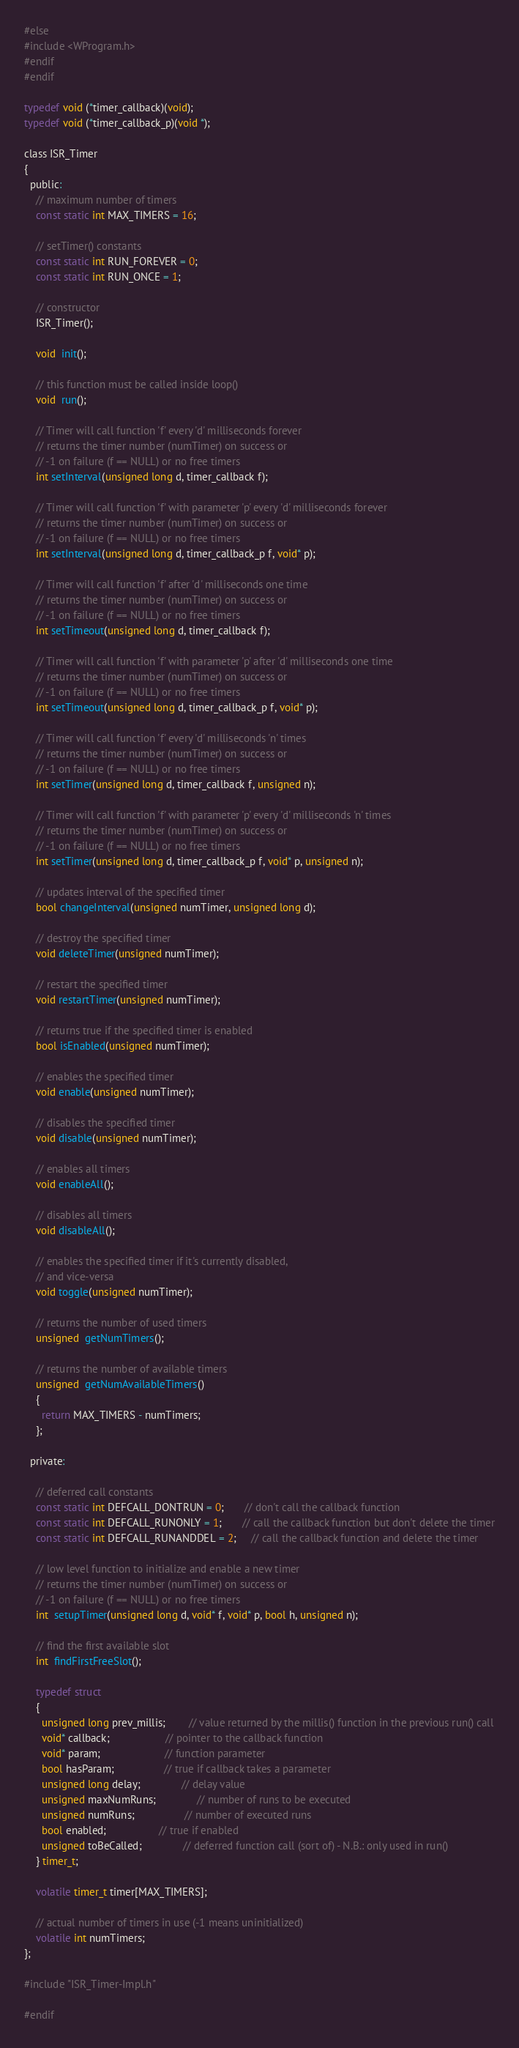<code> <loc_0><loc_0><loc_500><loc_500><_C_>#else
#include <WProgram.h>
#endif
#endif

typedef void (*timer_callback)(void);
typedef void (*timer_callback_p)(void *);

class ISR_Timer 
{
  public:
    // maximum number of timers
    const static int MAX_TIMERS = 16;

    // setTimer() constants
    const static int RUN_FOREVER = 0;
    const static int RUN_ONCE = 1;

    // constructor
    ISR_Timer();

    void  init();

    // this function must be called inside loop()
    void  run();

    // Timer will call function 'f' every 'd' milliseconds forever
    // returns the timer number (numTimer) on success or
    // -1 on failure (f == NULL) or no free timers
    int setInterval(unsigned long d, timer_callback f);

    // Timer will call function 'f' with parameter 'p' every 'd' milliseconds forever
    // returns the timer number (numTimer) on success or
    // -1 on failure (f == NULL) or no free timers
    int setInterval(unsigned long d, timer_callback_p f, void* p);

    // Timer will call function 'f' after 'd' milliseconds one time
    // returns the timer number (numTimer) on success or
    // -1 on failure (f == NULL) or no free timers
    int setTimeout(unsigned long d, timer_callback f);

    // Timer will call function 'f' with parameter 'p' after 'd' milliseconds one time
    // returns the timer number (numTimer) on success or
    // -1 on failure (f == NULL) or no free timers
    int setTimeout(unsigned long d, timer_callback_p f, void* p);

    // Timer will call function 'f' every 'd' milliseconds 'n' times
    // returns the timer number (numTimer) on success or
    // -1 on failure (f == NULL) or no free timers
    int setTimer(unsigned long d, timer_callback f, unsigned n);

    // Timer will call function 'f' with parameter 'p' every 'd' milliseconds 'n' times
    // returns the timer number (numTimer) on success or
    // -1 on failure (f == NULL) or no free timers
    int setTimer(unsigned long d, timer_callback_p f, void* p, unsigned n);

    // updates interval of the specified timer
    bool changeInterval(unsigned numTimer, unsigned long d);

    // destroy the specified timer
    void deleteTimer(unsigned numTimer);

    // restart the specified timer
    void restartTimer(unsigned numTimer);

    // returns true if the specified timer is enabled
    bool isEnabled(unsigned numTimer);

    // enables the specified timer
    void enable(unsigned numTimer);

    // disables the specified timer
    void disable(unsigned numTimer);

    // enables all timers
    void enableAll();

    // disables all timers
    void disableAll();

    // enables the specified timer if it's currently disabled,
    // and vice-versa
    void toggle(unsigned numTimer);

    // returns the number of used timers
    unsigned  getNumTimers();

    // returns the number of available timers
    unsigned  getNumAvailableTimers() 
    {
      return MAX_TIMERS - numTimers;
    };

  private:
  
    // deferred call constants
    const static int DEFCALL_DONTRUN = 0;       // don't call the callback function
    const static int DEFCALL_RUNONLY = 1;       // call the callback function but don't delete the timer
    const static int DEFCALL_RUNANDDEL = 2;     // call the callback function and delete the timer

    // low level function to initialize and enable a new timer
    // returns the timer number (numTimer) on success or
    // -1 on failure (f == NULL) or no free timers
    int  setupTimer(unsigned long d, void* f, void* p, bool h, unsigned n);

    // find the first available slot
    int  findFirstFreeSlot();

    typedef struct 
    {
      unsigned long prev_millis;        // value returned by the millis() function in the previous run() call
      void* callback;                   // pointer to the callback function
      void* param;                      // function parameter
      bool hasParam;                 // true if callback takes a parameter
      unsigned long delay;              // delay value
      unsigned maxNumRuns;              // number of runs to be executed
      unsigned numRuns;                 // number of executed runs
      bool enabled;                  // true if enabled
      unsigned toBeCalled;              // deferred function call (sort of) - N.B.: only used in run()
    } timer_t;

    volatile timer_t timer[MAX_TIMERS];

    // actual number of timers in use (-1 means uninitialized)
    volatile int numTimers;
};

#include "ISR_Timer-Impl.h"

#endif
</code> 